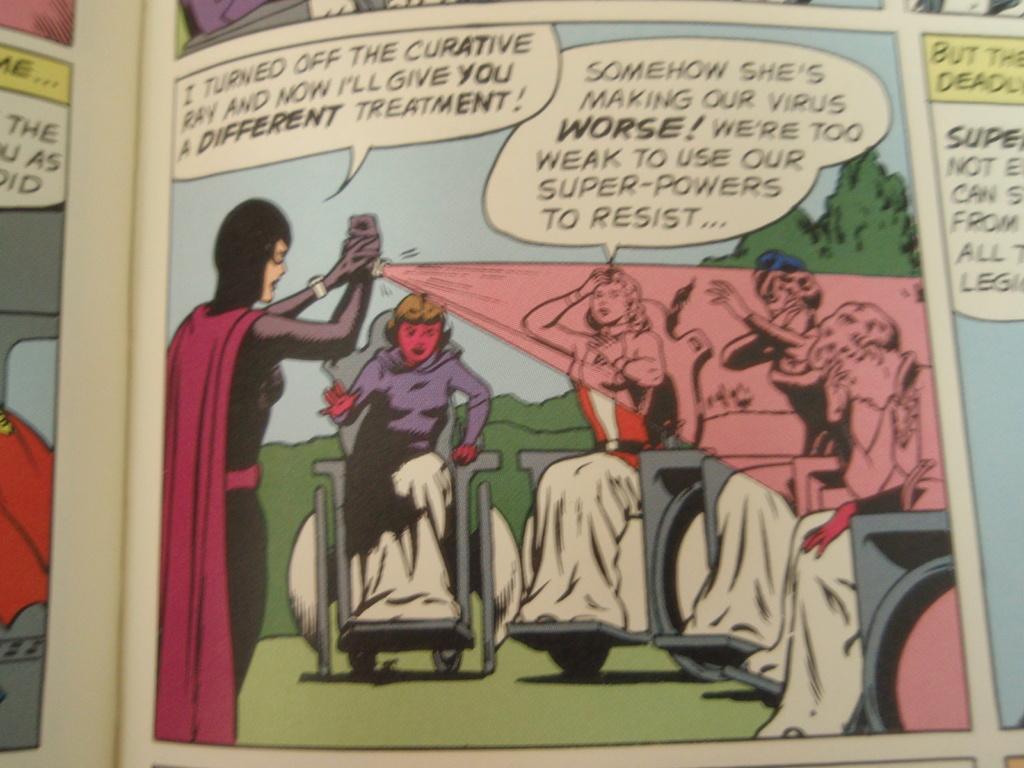What did the villain turn off?
Make the answer very short. The curative ray. What device is the villain holding?
Provide a short and direct response. Curative ray. 